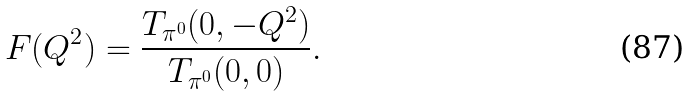Convert formula to latex. <formula><loc_0><loc_0><loc_500><loc_500>F ( Q ^ { 2 } ) = \frac { T _ { \pi ^ { 0 } } ( 0 , - Q ^ { 2 } ) } { T _ { \pi ^ { 0 } } ( 0 , 0 ) } .</formula> 